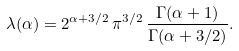Convert formula to latex. <formula><loc_0><loc_0><loc_500><loc_500>\lambda ( \alpha ) = 2 ^ { \alpha + 3 / 2 } \, \pi ^ { 3 / 2 } \, \frac { \Gamma ( \alpha + 1 ) } { \Gamma ( \alpha + 3 / 2 ) } .</formula> 